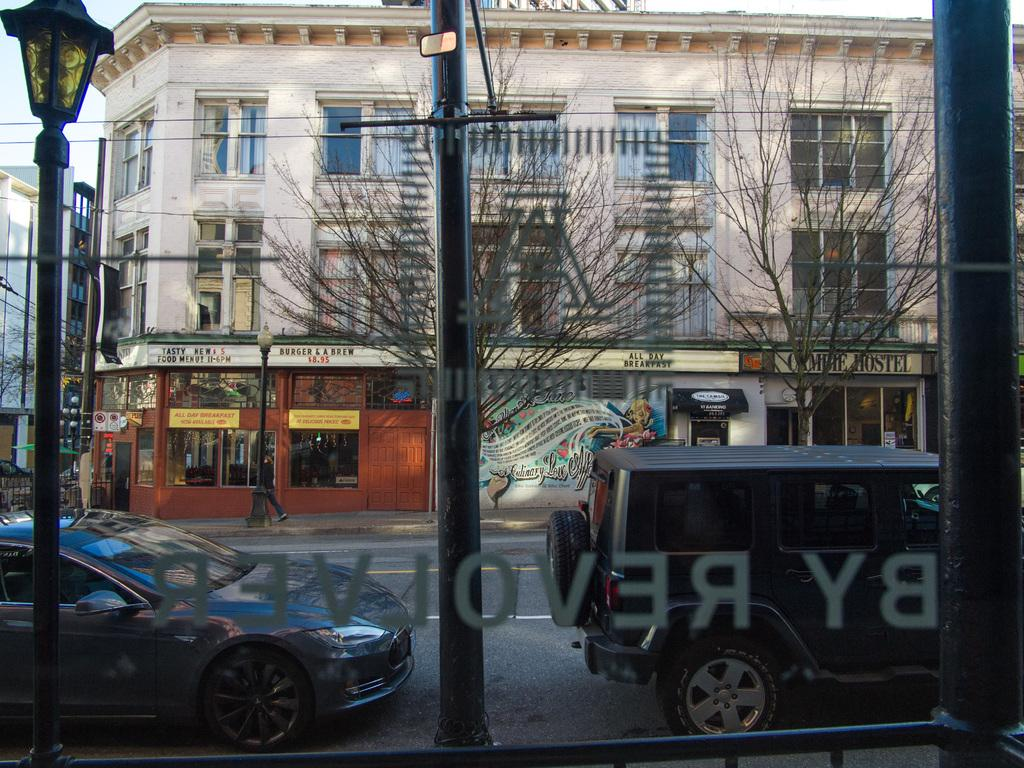What structures are present in the image? There are poles, trees, vehicles on the road, and buildings in the image. What feature do the buildings have? The buildings have windows. What can be seen in the background of the image? The sky is visible in the background of the image. What type of statement can be seen written on the trees in the image? There are no statements written on the trees in the image; the trees are natural vegetation. What kind of yam is being used as bait for the vehicles on the road? There is no yam or bait present in the image; the vehicles are simply driving on the road. 